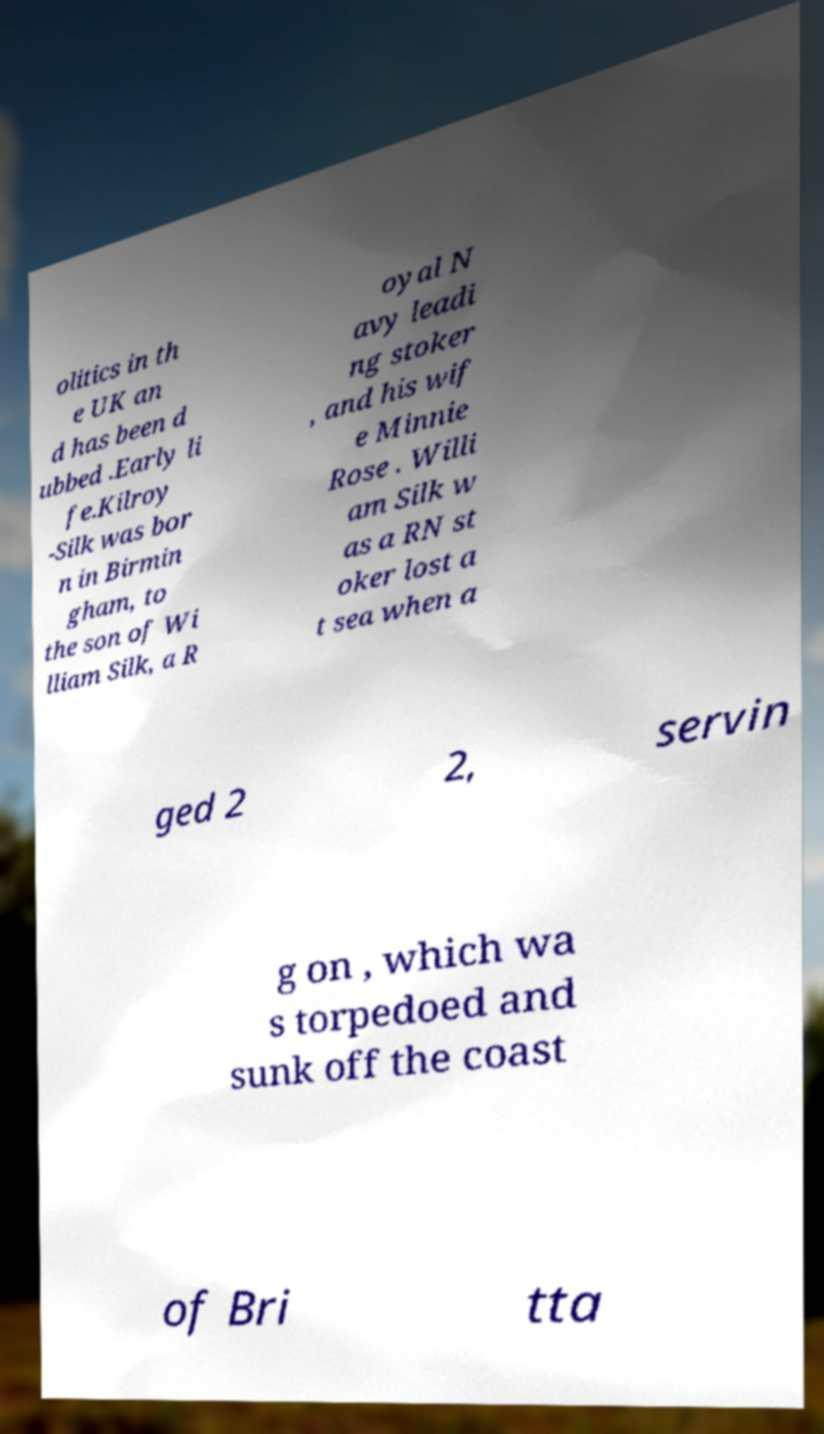Could you extract and type out the text from this image? olitics in th e UK an d has been d ubbed .Early li fe.Kilroy -Silk was bor n in Birmin gham, to the son of Wi lliam Silk, a R oyal N avy leadi ng stoker , and his wif e Minnie Rose . Willi am Silk w as a RN st oker lost a t sea when a ged 2 2, servin g on , which wa s torpedoed and sunk off the coast of Bri tta 